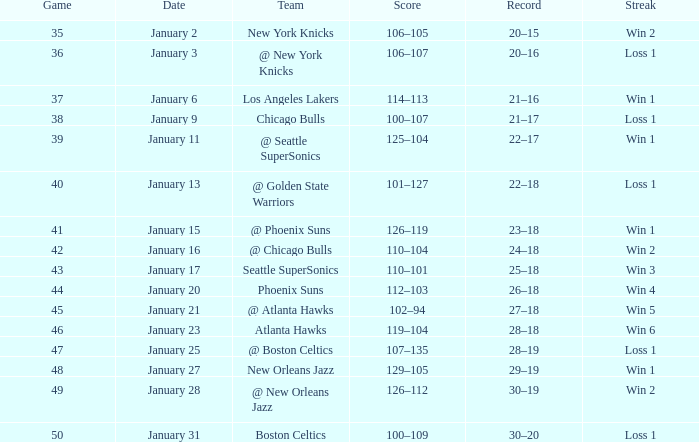What is the Team on January 20? Phoenix Suns. 